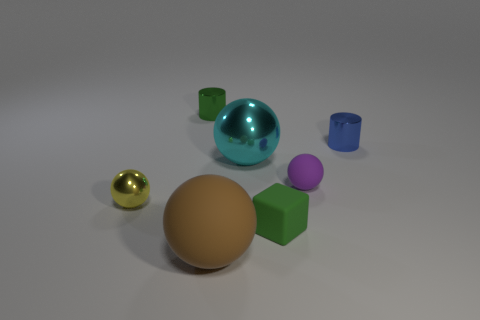Is there anything else that has the same shape as the green matte thing?
Your answer should be compact. No. There is a large object that is in front of the small green thing in front of the small yellow thing; what is it made of?
Provide a short and direct response. Rubber. Is there another metallic object that has the same shape as the tiny yellow metallic thing?
Make the answer very short. Yes. The big cyan shiny object has what shape?
Offer a very short reply. Sphere. What is the material of the green thing in front of the tiny cylinder right of the matte thing that is to the right of the green block?
Your answer should be compact. Rubber. Is the number of shiny spheres that are on the right side of the big brown ball greater than the number of metallic blocks?
Keep it short and to the point. Yes. There is a purple ball that is the same size as the blue shiny thing; what is its material?
Offer a terse response. Rubber. Is there a purple rubber object of the same size as the blue metallic cylinder?
Ensure brevity in your answer.  Yes. There is a matte sphere in front of the purple object; what is its size?
Offer a terse response. Large. What is the size of the brown object?
Give a very brief answer. Large. 